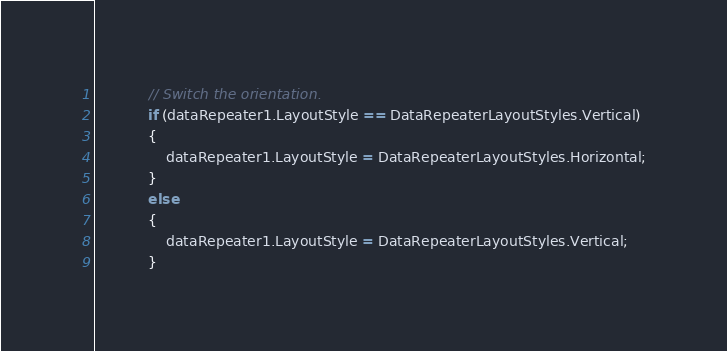<code> <loc_0><loc_0><loc_500><loc_500><_C#_>            // Switch the orientation.
            if (dataRepeater1.LayoutStyle == DataRepeaterLayoutStyles.Vertical)
            {
                dataRepeater1.LayoutStyle = DataRepeaterLayoutStyles.Horizontal;
            }
            else
            {
                dataRepeater1.LayoutStyle = DataRepeaterLayoutStyles.Vertical;
            }            </code> 